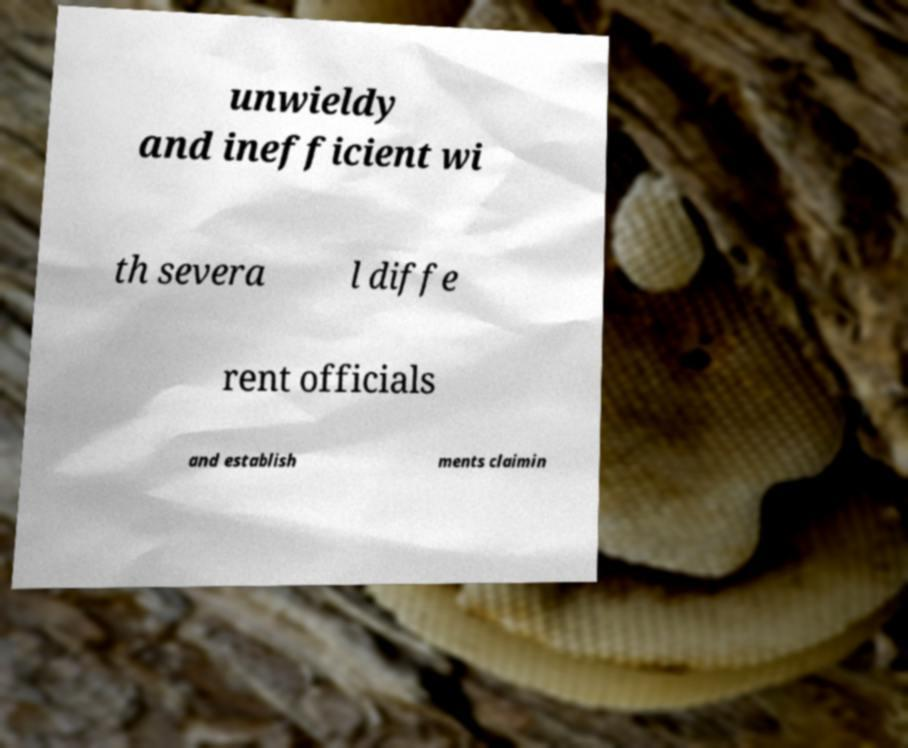For documentation purposes, I need the text within this image transcribed. Could you provide that? unwieldy and inefficient wi th severa l diffe rent officials and establish ments claimin 